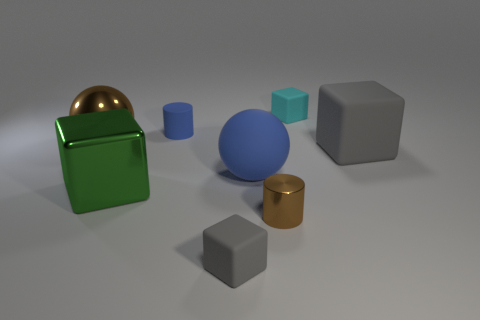How many cubes are either big purple metallic things or blue matte objects?
Your response must be concise. 0. Does the small gray thing have the same shape as the small matte thing that is behind the tiny rubber cylinder?
Your response must be concise. Yes. Is the number of metal balls that are to the right of the large blue object less than the number of large purple spheres?
Give a very brief answer. No. Are there any small cyan rubber objects to the right of the cyan matte object?
Your response must be concise. No. Are there any tiny blue rubber objects that have the same shape as the tiny brown thing?
Ensure brevity in your answer.  Yes. There is a brown metal thing that is the same size as the green thing; what shape is it?
Your answer should be compact. Sphere. How many things are cylinders that are behind the big gray rubber cube or large blue objects?
Give a very brief answer. 2. Does the matte cylinder have the same color as the large rubber ball?
Ensure brevity in your answer.  Yes. There is a gray object that is in front of the brown metal cylinder; how big is it?
Your answer should be very brief. Small. Are there any brown shiny cylinders of the same size as the blue cylinder?
Ensure brevity in your answer.  Yes. 